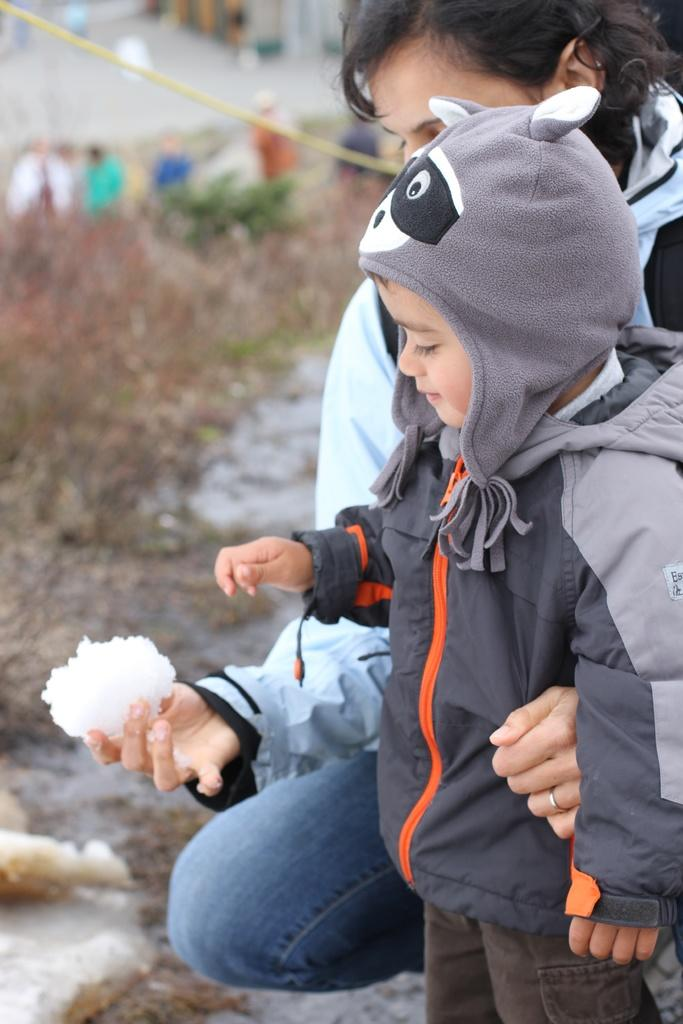How many people can be seen in the image? There are a few people in the image. Which two people are specifically highlighted in the image? Two people are highlighted in the image. What is the person holding in the image? There is a person holding an object in the image. What can be seen beneath the people in the image? The ground is visible in the image. How would you describe the background of the image? The background of the image is blurred. What type of fuel is being used by the person in the image? There is no indication of fuel usage in the image; it does not feature any vehicles or machinery that would require fuel. 